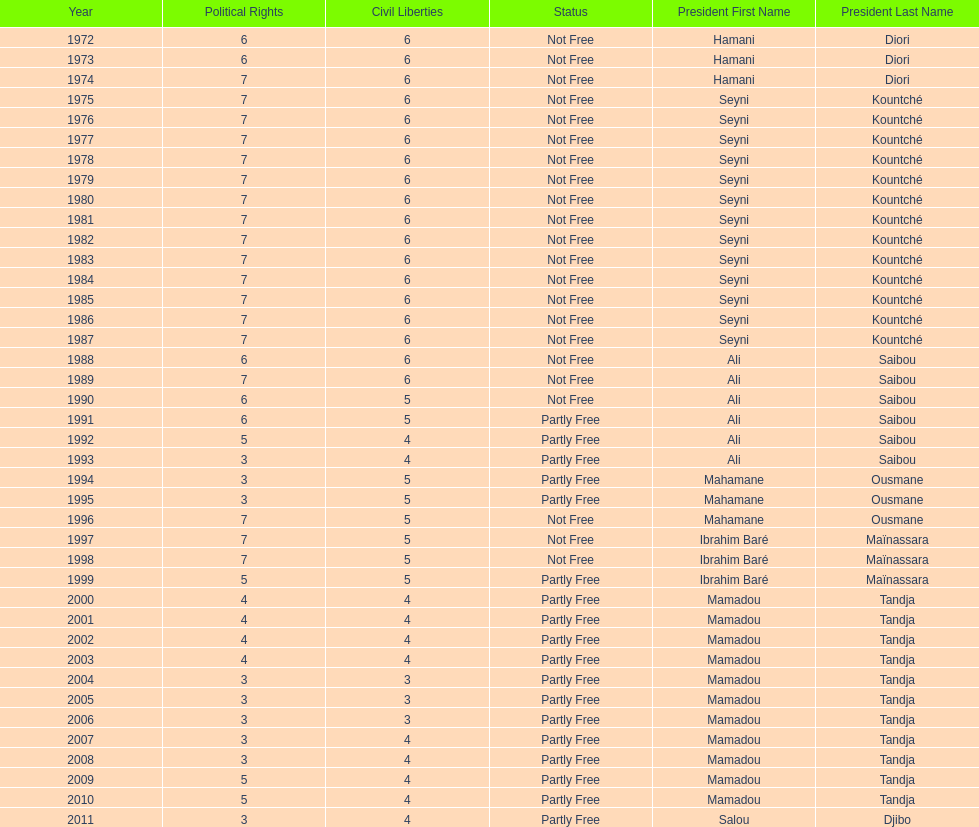How many years was ali saibou president? 6. 